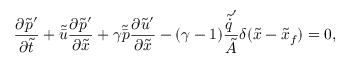Convert formula to latex. <formula><loc_0><loc_0><loc_500><loc_500>{ \frac { \partial \tilde { p } ^ { \prime } } { \partial \tilde { t } } } + \tilde { \bar { u } } { \frac { \partial \tilde { p } ^ { \prime } } { \partial \tilde { x } } } + \gamma \tilde { \bar { p } } { \frac { \partial \tilde { u } ^ { \prime } } { \partial \tilde { x } } } - ( \gamma - 1 ) \frac { \tilde { \dot { q } } ^ { \prime } } { \tilde { A } } \delta ( \tilde { x } - \tilde { x } _ { f } ) = 0 ,</formula> 